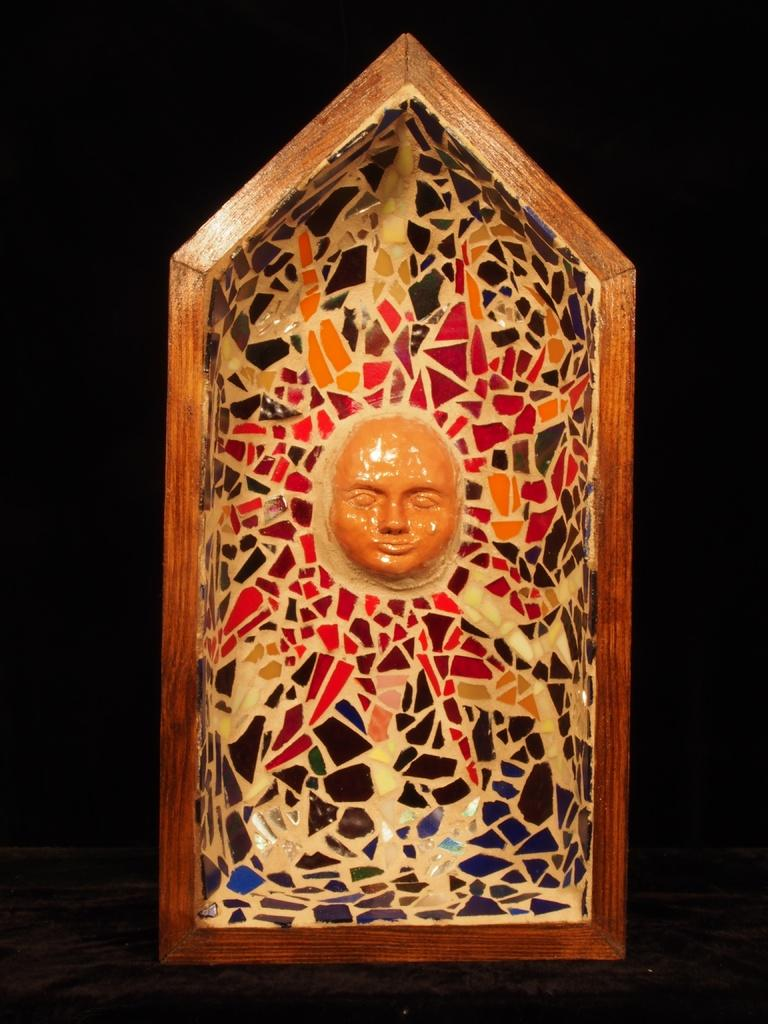What is the main subject of the image? The main subject of the image is visual art on a wooden block. Can you describe the background of the image? The background of the image is dark. What type of payment is being made for the dinner in the image? There is no dinner or payment present in the image; it only features visual art on a wooden block with a dark background. 